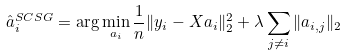Convert formula to latex. <formula><loc_0><loc_0><loc_500><loc_500>\hat { a } _ { i } ^ { S C S G } = \arg \min _ { a _ { i } } \frac { 1 } { n } \| y _ { i } - X a _ { i } \| _ { 2 } ^ { 2 } + \lambda \sum _ { j \neq i } \| a _ { i , j } \| _ { 2 }</formula> 